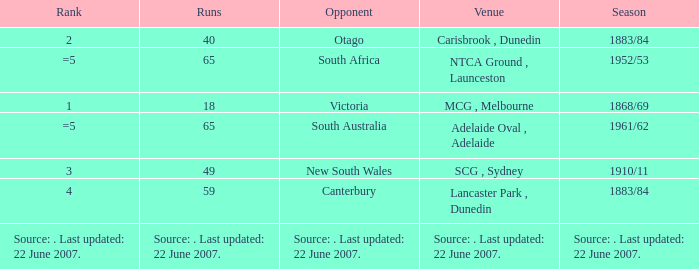Which Runs has a Rank of =5 and an Opponent of south australia? 65.0. 